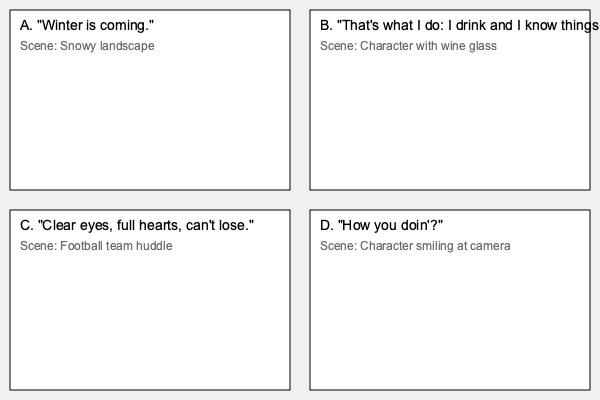Match the following TV show quotes to their corresponding visual scenes:

1. "Winter is coming."
2. "That's what I do: I drink and I know things."
3. "Clear eyes, full hearts, can't lose."
4. "How you doin'?" To match the TV show quotes to their corresponding visual scenes, we need to analyze each quote and scene description:

1. "Winter is coming." - This is a famous quote from HBO's "Game of Thrones." It corresponds to scene A, which describes a snowy landscape, fitting the ominous warning about winter.

2. "That's what I do: I drink and I know things." - This quote is also from "Game of Thrones," specifically said by Tyrion Lannister. It matches scene B, which shows a character with a wine glass, aligning with Tyrion's love for drinking.

3. "Clear eyes, full hearts, can't lose." - This is a motivational quote from NBC's "Friday Night Lights," often said by Coach Taylor to his football team. It corresponds to scene C, which depicts a football team huddle.

4. "How you doin'?" - This is Joey Tribbiani's catchphrase from NBC's "Friends." It matches scene D, which shows a character smiling at the camera, fitting Joey's flirtatious nature when delivering this line.

Therefore, the correct matching is:
1-A, 2-B, 3-C, 4-D
Answer: 1-A, 2-B, 3-C, 4-D 